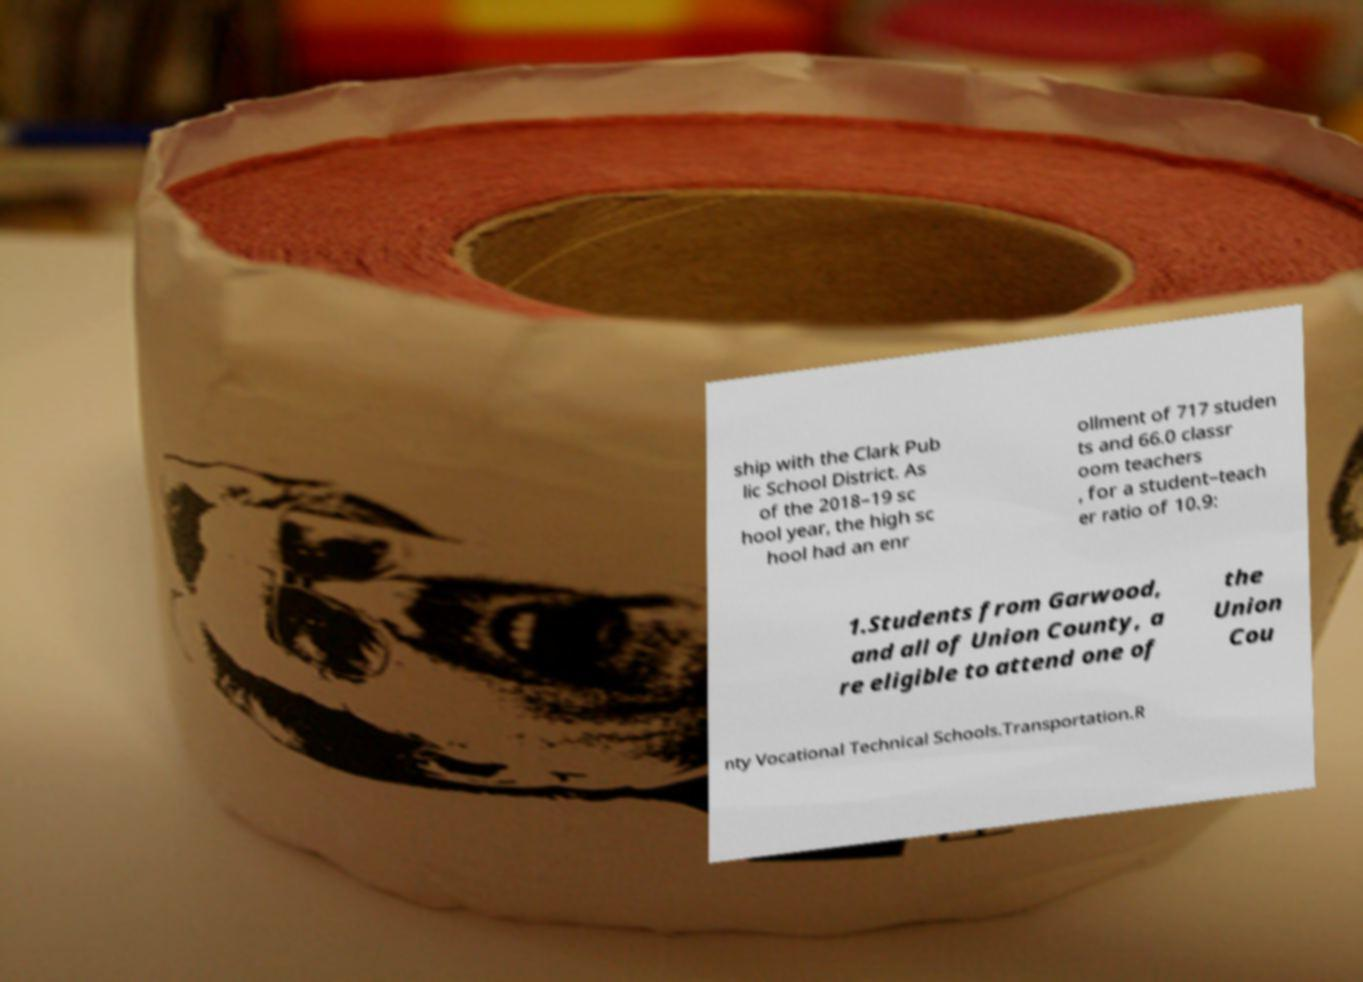Please read and relay the text visible in this image. What does it say? ship with the Clark Pub lic School District. As of the 2018–19 sc hool year, the high sc hool had an enr ollment of 717 studen ts and 66.0 classr oom teachers , for a student–teach er ratio of 10.9: 1.Students from Garwood, and all of Union County, a re eligible to attend one of the Union Cou nty Vocational Technical Schools.Transportation.R 